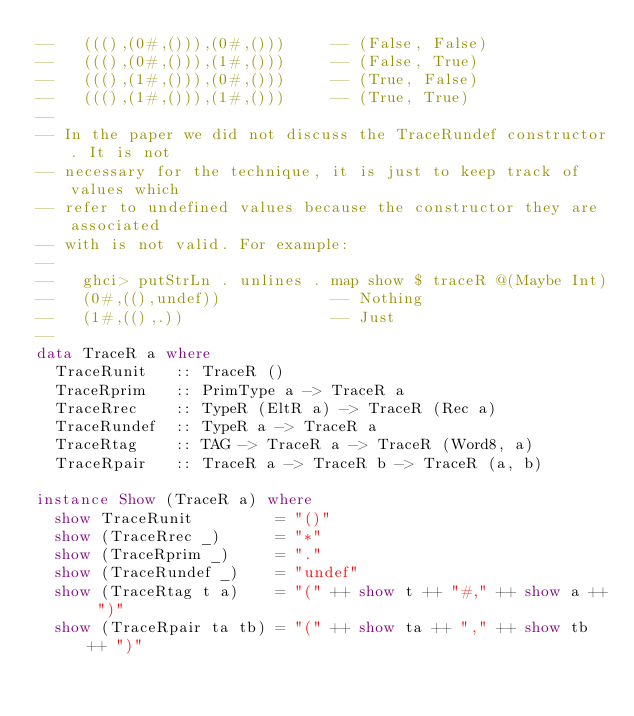<code> <loc_0><loc_0><loc_500><loc_500><_Haskell_>--   (((),(0#,())),(0#,()))     -- (False, False)
--   (((),(0#,())),(1#,()))     -- (False, True)
--   (((),(1#,())),(0#,()))     -- (True, False)
--   (((),(1#,())),(1#,()))     -- (True, True)
--
-- In the paper we did not discuss the TraceRundef constructor. It is not
-- necessary for the technique, it is just to keep track of values which
-- refer to undefined values because the constructor they are associated
-- with is not valid. For example:
--
--   ghci> putStrLn . unlines . map show $ traceR @(Maybe Int)
--   (0#,((),undef))            -- Nothing
--   (1#,((),.))                -- Just
--
data TraceR a where
  TraceRunit   :: TraceR ()
  TraceRprim   :: PrimType a -> TraceR a
  TraceRrec    :: TypeR (EltR a) -> TraceR (Rec a)
  TraceRundef  :: TypeR a -> TraceR a
  TraceRtag    :: TAG -> TraceR a -> TraceR (Word8, a)
  TraceRpair   :: TraceR a -> TraceR b -> TraceR (a, b)

instance Show (TraceR a) where
  show TraceRunit         = "()"
  show (TraceRrec _)      = "*"
  show (TraceRprim _)     = "."
  show (TraceRundef _)    = "undef"
  show (TraceRtag t a)    = "(" ++ show t ++ "#," ++ show a ++ ")"
  show (TraceRpair ta tb) = "(" ++ show ta ++ "," ++ show tb ++ ")"

</code> 